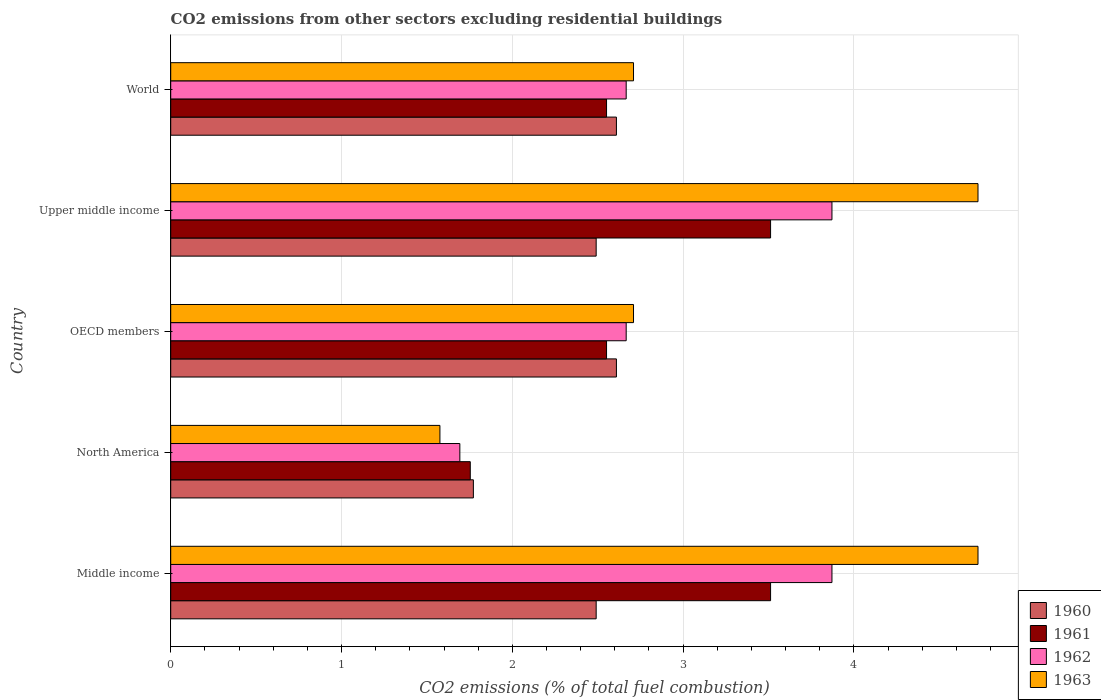How many groups of bars are there?
Ensure brevity in your answer.  5. How many bars are there on the 5th tick from the top?
Provide a short and direct response. 4. What is the total CO2 emitted in 1961 in Upper middle income?
Keep it short and to the point. 3.51. Across all countries, what is the maximum total CO2 emitted in 1960?
Give a very brief answer. 2.61. Across all countries, what is the minimum total CO2 emitted in 1961?
Offer a very short reply. 1.75. What is the total total CO2 emitted in 1961 in the graph?
Offer a very short reply. 13.88. What is the difference between the total CO2 emitted in 1962 in North America and that in OECD members?
Your response must be concise. -0.97. What is the difference between the total CO2 emitted in 1961 in OECD members and the total CO2 emitted in 1962 in North America?
Your answer should be compact. 0.86. What is the average total CO2 emitted in 1961 per country?
Provide a short and direct response. 2.78. What is the difference between the total CO2 emitted in 1962 and total CO2 emitted in 1961 in Middle income?
Ensure brevity in your answer.  0.36. What is the ratio of the total CO2 emitted in 1961 in North America to that in World?
Ensure brevity in your answer.  0.69. Is the total CO2 emitted in 1960 in Middle income less than that in World?
Keep it short and to the point. Yes. Is the difference between the total CO2 emitted in 1962 in Middle income and Upper middle income greater than the difference between the total CO2 emitted in 1961 in Middle income and Upper middle income?
Make the answer very short. No. What is the difference between the highest and the lowest total CO2 emitted in 1963?
Your response must be concise. 3.15. Is it the case that in every country, the sum of the total CO2 emitted in 1962 and total CO2 emitted in 1961 is greater than the sum of total CO2 emitted in 1963 and total CO2 emitted in 1960?
Provide a succinct answer. No. How many bars are there?
Provide a short and direct response. 20. Are all the bars in the graph horizontal?
Your answer should be compact. Yes. Are the values on the major ticks of X-axis written in scientific E-notation?
Your response must be concise. No. Does the graph contain grids?
Your answer should be very brief. Yes. How are the legend labels stacked?
Give a very brief answer. Vertical. What is the title of the graph?
Make the answer very short. CO2 emissions from other sectors excluding residential buildings. What is the label or title of the X-axis?
Keep it short and to the point. CO2 emissions (% of total fuel combustion). What is the CO2 emissions (% of total fuel combustion) in 1960 in Middle income?
Keep it short and to the point. 2.49. What is the CO2 emissions (% of total fuel combustion) of 1961 in Middle income?
Give a very brief answer. 3.51. What is the CO2 emissions (% of total fuel combustion) of 1962 in Middle income?
Offer a terse response. 3.87. What is the CO2 emissions (% of total fuel combustion) of 1963 in Middle income?
Provide a succinct answer. 4.73. What is the CO2 emissions (% of total fuel combustion) of 1960 in North America?
Provide a succinct answer. 1.77. What is the CO2 emissions (% of total fuel combustion) of 1961 in North America?
Offer a very short reply. 1.75. What is the CO2 emissions (% of total fuel combustion) in 1962 in North America?
Your response must be concise. 1.69. What is the CO2 emissions (% of total fuel combustion) in 1963 in North America?
Your answer should be compact. 1.58. What is the CO2 emissions (% of total fuel combustion) in 1960 in OECD members?
Provide a short and direct response. 2.61. What is the CO2 emissions (% of total fuel combustion) in 1961 in OECD members?
Your response must be concise. 2.55. What is the CO2 emissions (% of total fuel combustion) of 1962 in OECD members?
Ensure brevity in your answer.  2.67. What is the CO2 emissions (% of total fuel combustion) in 1963 in OECD members?
Make the answer very short. 2.71. What is the CO2 emissions (% of total fuel combustion) of 1960 in Upper middle income?
Your answer should be compact. 2.49. What is the CO2 emissions (% of total fuel combustion) of 1961 in Upper middle income?
Give a very brief answer. 3.51. What is the CO2 emissions (% of total fuel combustion) in 1962 in Upper middle income?
Your response must be concise. 3.87. What is the CO2 emissions (% of total fuel combustion) of 1963 in Upper middle income?
Offer a very short reply. 4.73. What is the CO2 emissions (% of total fuel combustion) in 1960 in World?
Make the answer very short. 2.61. What is the CO2 emissions (% of total fuel combustion) of 1961 in World?
Offer a terse response. 2.55. What is the CO2 emissions (% of total fuel combustion) in 1962 in World?
Offer a very short reply. 2.67. What is the CO2 emissions (% of total fuel combustion) in 1963 in World?
Ensure brevity in your answer.  2.71. Across all countries, what is the maximum CO2 emissions (% of total fuel combustion) in 1960?
Make the answer very short. 2.61. Across all countries, what is the maximum CO2 emissions (% of total fuel combustion) in 1961?
Offer a terse response. 3.51. Across all countries, what is the maximum CO2 emissions (% of total fuel combustion) in 1962?
Keep it short and to the point. 3.87. Across all countries, what is the maximum CO2 emissions (% of total fuel combustion) in 1963?
Keep it short and to the point. 4.73. Across all countries, what is the minimum CO2 emissions (% of total fuel combustion) in 1960?
Your response must be concise. 1.77. Across all countries, what is the minimum CO2 emissions (% of total fuel combustion) of 1961?
Keep it short and to the point. 1.75. Across all countries, what is the minimum CO2 emissions (% of total fuel combustion) of 1962?
Ensure brevity in your answer.  1.69. Across all countries, what is the minimum CO2 emissions (% of total fuel combustion) in 1963?
Your answer should be very brief. 1.58. What is the total CO2 emissions (% of total fuel combustion) in 1960 in the graph?
Provide a short and direct response. 11.97. What is the total CO2 emissions (% of total fuel combustion) of 1961 in the graph?
Provide a succinct answer. 13.88. What is the total CO2 emissions (% of total fuel combustion) of 1962 in the graph?
Your answer should be compact. 14.77. What is the total CO2 emissions (% of total fuel combustion) in 1963 in the graph?
Provide a succinct answer. 16.45. What is the difference between the CO2 emissions (% of total fuel combustion) of 1960 in Middle income and that in North America?
Your answer should be very brief. 0.72. What is the difference between the CO2 emissions (% of total fuel combustion) of 1961 in Middle income and that in North America?
Provide a short and direct response. 1.76. What is the difference between the CO2 emissions (% of total fuel combustion) of 1962 in Middle income and that in North America?
Offer a very short reply. 2.18. What is the difference between the CO2 emissions (% of total fuel combustion) in 1963 in Middle income and that in North America?
Make the answer very short. 3.15. What is the difference between the CO2 emissions (% of total fuel combustion) in 1960 in Middle income and that in OECD members?
Provide a short and direct response. -0.12. What is the difference between the CO2 emissions (% of total fuel combustion) in 1961 in Middle income and that in OECD members?
Keep it short and to the point. 0.96. What is the difference between the CO2 emissions (% of total fuel combustion) in 1962 in Middle income and that in OECD members?
Keep it short and to the point. 1.2. What is the difference between the CO2 emissions (% of total fuel combustion) of 1963 in Middle income and that in OECD members?
Make the answer very short. 2.02. What is the difference between the CO2 emissions (% of total fuel combustion) of 1960 in Middle income and that in Upper middle income?
Ensure brevity in your answer.  0. What is the difference between the CO2 emissions (% of total fuel combustion) of 1963 in Middle income and that in Upper middle income?
Your answer should be compact. 0. What is the difference between the CO2 emissions (% of total fuel combustion) in 1960 in Middle income and that in World?
Your response must be concise. -0.12. What is the difference between the CO2 emissions (% of total fuel combustion) of 1961 in Middle income and that in World?
Keep it short and to the point. 0.96. What is the difference between the CO2 emissions (% of total fuel combustion) of 1962 in Middle income and that in World?
Keep it short and to the point. 1.2. What is the difference between the CO2 emissions (% of total fuel combustion) of 1963 in Middle income and that in World?
Offer a terse response. 2.02. What is the difference between the CO2 emissions (% of total fuel combustion) in 1960 in North America and that in OECD members?
Your answer should be compact. -0.84. What is the difference between the CO2 emissions (% of total fuel combustion) of 1961 in North America and that in OECD members?
Make the answer very short. -0.8. What is the difference between the CO2 emissions (% of total fuel combustion) in 1962 in North America and that in OECD members?
Keep it short and to the point. -0.97. What is the difference between the CO2 emissions (% of total fuel combustion) in 1963 in North America and that in OECD members?
Offer a terse response. -1.13. What is the difference between the CO2 emissions (% of total fuel combustion) in 1960 in North America and that in Upper middle income?
Your answer should be compact. -0.72. What is the difference between the CO2 emissions (% of total fuel combustion) of 1961 in North America and that in Upper middle income?
Offer a terse response. -1.76. What is the difference between the CO2 emissions (% of total fuel combustion) in 1962 in North America and that in Upper middle income?
Your response must be concise. -2.18. What is the difference between the CO2 emissions (% of total fuel combustion) of 1963 in North America and that in Upper middle income?
Your response must be concise. -3.15. What is the difference between the CO2 emissions (% of total fuel combustion) in 1960 in North America and that in World?
Offer a very short reply. -0.84. What is the difference between the CO2 emissions (% of total fuel combustion) in 1961 in North America and that in World?
Offer a very short reply. -0.8. What is the difference between the CO2 emissions (% of total fuel combustion) of 1962 in North America and that in World?
Offer a very short reply. -0.97. What is the difference between the CO2 emissions (% of total fuel combustion) in 1963 in North America and that in World?
Ensure brevity in your answer.  -1.13. What is the difference between the CO2 emissions (% of total fuel combustion) in 1960 in OECD members and that in Upper middle income?
Offer a very short reply. 0.12. What is the difference between the CO2 emissions (% of total fuel combustion) in 1961 in OECD members and that in Upper middle income?
Your answer should be very brief. -0.96. What is the difference between the CO2 emissions (% of total fuel combustion) of 1962 in OECD members and that in Upper middle income?
Your answer should be very brief. -1.2. What is the difference between the CO2 emissions (% of total fuel combustion) of 1963 in OECD members and that in Upper middle income?
Offer a terse response. -2.02. What is the difference between the CO2 emissions (% of total fuel combustion) in 1961 in OECD members and that in World?
Offer a very short reply. 0. What is the difference between the CO2 emissions (% of total fuel combustion) in 1962 in OECD members and that in World?
Your answer should be very brief. 0. What is the difference between the CO2 emissions (% of total fuel combustion) in 1960 in Upper middle income and that in World?
Your answer should be compact. -0.12. What is the difference between the CO2 emissions (% of total fuel combustion) of 1961 in Upper middle income and that in World?
Provide a short and direct response. 0.96. What is the difference between the CO2 emissions (% of total fuel combustion) of 1962 in Upper middle income and that in World?
Your answer should be very brief. 1.2. What is the difference between the CO2 emissions (% of total fuel combustion) in 1963 in Upper middle income and that in World?
Provide a succinct answer. 2.02. What is the difference between the CO2 emissions (% of total fuel combustion) in 1960 in Middle income and the CO2 emissions (% of total fuel combustion) in 1961 in North America?
Give a very brief answer. 0.74. What is the difference between the CO2 emissions (% of total fuel combustion) in 1960 in Middle income and the CO2 emissions (% of total fuel combustion) in 1962 in North America?
Your answer should be very brief. 0.8. What is the difference between the CO2 emissions (% of total fuel combustion) of 1960 in Middle income and the CO2 emissions (% of total fuel combustion) of 1963 in North America?
Make the answer very short. 0.91. What is the difference between the CO2 emissions (% of total fuel combustion) in 1961 in Middle income and the CO2 emissions (% of total fuel combustion) in 1962 in North America?
Offer a terse response. 1.82. What is the difference between the CO2 emissions (% of total fuel combustion) of 1961 in Middle income and the CO2 emissions (% of total fuel combustion) of 1963 in North America?
Provide a short and direct response. 1.94. What is the difference between the CO2 emissions (% of total fuel combustion) in 1962 in Middle income and the CO2 emissions (% of total fuel combustion) in 1963 in North America?
Your response must be concise. 2.3. What is the difference between the CO2 emissions (% of total fuel combustion) of 1960 in Middle income and the CO2 emissions (% of total fuel combustion) of 1961 in OECD members?
Your response must be concise. -0.06. What is the difference between the CO2 emissions (% of total fuel combustion) of 1960 in Middle income and the CO2 emissions (% of total fuel combustion) of 1962 in OECD members?
Offer a very short reply. -0.18. What is the difference between the CO2 emissions (% of total fuel combustion) in 1960 in Middle income and the CO2 emissions (% of total fuel combustion) in 1963 in OECD members?
Ensure brevity in your answer.  -0.22. What is the difference between the CO2 emissions (% of total fuel combustion) in 1961 in Middle income and the CO2 emissions (% of total fuel combustion) in 1962 in OECD members?
Provide a succinct answer. 0.85. What is the difference between the CO2 emissions (% of total fuel combustion) of 1961 in Middle income and the CO2 emissions (% of total fuel combustion) of 1963 in OECD members?
Offer a very short reply. 0.8. What is the difference between the CO2 emissions (% of total fuel combustion) of 1962 in Middle income and the CO2 emissions (% of total fuel combustion) of 1963 in OECD members?
Provide a short and direct response. 1.16. What is the difference between the CO2 emissions (% of total fuel combustion) in 1960 in Middle income and the CO2 emissions (% of total fuel combustion) in 1961 in Upper middle income?
Your answer should be very brief. -1.02. What is the difference between the CO2 emissions (% of total fuel combustion) of 1960 in Middle income and the CO2 emissions (% of total fuel combustion) of 1962 in Upper middle income?
Make the answer very short. -1.38. What is the difference between the CO2 emissions (% of total fuel combustion) of 1960 in Middle income and the CO2 emissions (% of total fuel combustion) of 1963 in Upper middle income?
Give a very brief answer. -2.24. What is the difference between the CO2 emissions (% of total fuel combustion) of 1961 in Middle income and the CO2 emissions (% of total fuel combustion) of 1962 in Upper middle income?
Offer a very short reply. -0.36. What is the difference between the CO2 emissions (% of total fuel combustion) in 1961 in Middle income and the CO2 emissions (% of total fuel combustion) in 1963 in Upper middle income?
Your answer should be compact. -1.21. What is the difference between the CO2 emissions (% of total fuel combustion) of 1962 in Middle income and the CO2 emissions (% of total fuel combustion) of 1963 in Upper middle income?
Your answer should be very brief. -0.85. What is the difference between the CO2 emissions (% of total fuel combustion) of 1960 in Middle income and the CO2 emissions (% of total fuel combustion) of 1961 in World?
Make the answer very short. -0.06. What is the difference between the CO2 emissions (% of total fuel combustion) in 1960 in Middle income and the CO2 emissions (% of total fuel combustion) in 1962 in World?
Offer a terse response. -0.18. What is the difference between the CO2 emissions (% of total fuel combustion) of 1960 in Middle income and the CO2 emissions (% of total fuel combustion) of 1963 in World?
Make the answer very short. -0.22. What is the difference between the CO2 emissions (% of total fuel combustion) of 1961 in Middle income and the CO2 emissions (% of total fuel combustion) of 1962 in World?
Provide a succinct answer. 0.85. What is the difference between the CO2 emissions (% of total fuel combustion) in 1961 in Middle income and the CO2 emissions (% of total fuel combustion) in 1963 in World?
Ensure brevity in your answer.  0.8. What is the difference between the CO2 emissions (% of total fuel combustion) in 1962 in Middle income and the CO2 emissions (% of total fuel combustion) in 1963 in World?
Give a very brief answer. 1.16. What is the difference between the CO2 emissions (% of total fuel combustion) in 1960 in North America and the CO2 emissions (% of total fuel combustion) in 1961 in OECD members?
Offer a very short reply. -0.78. What is the difference between the CO2 emissions (% of total fuel combustion) of 1960 in North America and the CO2 emissions (% of total fuel combustion) of 1962 in OECD members?
Offer a very short reply. -0.89. What is the difference between the CO2 emissions (% of total fuel combustion) in 1960 in North America and the CO2 emissions (% of total fuel combustion) in 1963 in OECD members?
Provide a succinct answer. -0.94. What is the difference between the CO2 emissions (% of total fuel combustion) of 1961 in North America and the CO2 emissions (% of total fuel combustion) of 1962 in OECD members?
Your answer should be very brief. -0.91. What is the difference between the CO2 emissions (% of total fuel combustion) of 1961 in North America and the CO2 emissions (% of total fuel combustion) of 1963 in OECD members?
Provide a short and direct response. -0.96. What is the difference between the CO2 emissions (% of total fuel combustion) of 1962 in North America and the CO2 emissions (% of total fuel combustion) of 1963 in OECD members?
Your response must be concise. -1.02. What is the difference between the CO2 emissions (% of total fuel combustion) in 1960 in North America and the CO2 emissions (% of total fuel combustion) in 1961 in Upper middle income?
Ensure brevity in your answer.  -1.74. What is the difference between the CO2 emissions (% of total fuel combustion) of 1960 in North America and the CO2 emissions (% of total fuel combustion) of 1962 in Upper middle income?
Offer a very short reply. -2.1. What is the difference between the CO2 emissions (% of total fuel combustion) in 1960 in North America and the CO2 emissions (% of total fuel combustion) in 1963 in Upper middle income?
Offer a terse response. -2.95. What is the difference between the CO2 emissions (% of total fuel combustion) of 1961 in North America and the CO2 emissions (% of total fuel combustion) of 1962 in Upper middle income?
Make the answer very short. -2.12. What is the difference between the CO2 emissions (% of total fuel combustion) of 1961 in North America and the CO2 emissions (% of total fuel combustion) of 1963 in Upper middle income?
Your answer should be very brief. -2.97. What is the difference between the CO2 emissions (% of total fuel combustion) of 1962 in North America and the CO2 emissions (% of total fuel combustion) of 1963 in Upper middle income?
Ensure brevity in your answer.  -3.03. What is the difference between the CO2 emissions (% of total fuel combustion) of 1960 in North America and the CO2 emissions (% of total fuel combustion) of 1961 in World?
Keep it short and to the point. -0.78. What is the difference between the CO2 emissions (% of total fuel combustion) of 1960 in North America and the CO2 emissions (% of total fuel combustion) of 1962 in World?
Make the answer very short. -0.89. What is the difference between the CO2 emissions (% of total fuel combustion) of 1960 in North America and the CO2 emissions (% of total fuel combustion) of 1963 in World?
Offer a terse response. -0.94. What is the difference between the CO2 emissions (% of total fuel combustion) in 1961 in North America and the CO2 emissions (% of total fuel combustion) in 1962 in World?
Provide a succinct answer. -0.91. What is the difference between the CO2 emissions (% of total fuel combustion) of 1961 in North America and the CO2 emissions (% of total fuel combustion) of 1963 in World?
Provide a short and direct response. -0.96. What is the difference between the CO2 emissions (% of total fuel combustion) in 1962 in North America and the CO2 emissions (% of total fuel combustion) in 1963 in World?
Keep it short and to the point. -1.02. What is the difference between the CO2 emissions (% of total fuel combustion) of 1960 in OECD members and the CO2 emissions (% of total fuel combustion) of 1961 in Upper middle income?
Make the answer very short. -0.9. What is the difference between the CO2 emissions (% of total fuel combustion) of 1960 in OECD members and the CO2 emissions (% of total fuel combustion) of 1962 in Upper middle income?
Offer a terse response. -1.26. What is the difference between the CO2 emissions (% of total fuel combustion) of 1960 in OECD members and the CO2 emissions (% of total fuel combustion) of 1963 in Upper middle income?
Keep it short and to the point. -2.12. What is the difference between the CO2 emissions (% of total fuel combustion) of 1961 in OECD members and the CO2 emissions (% of total fuel combustion) of 1962 in Upper middle income?
Make the answer very short. -1.32. What is the difference between the CO2 emissions (% of total fuel combustion) of 1961 in OECD members and the CO2 emissions (% of total fuel combustion) of 1963 in Upper middle income?
Ensure brevity in your answer.  -2.17. What is the difference between the CO2 emissions (% of total fuel combustion) of 1962 in OECD members and the CO2 emissions (% of total fuel combustion) of 1963 in Upper middle income?
Offer a terse response. -2.06. What is the difference between the CO2 emissions (% of total fuel combustion) of 1960 in OECD members and the CO2 emissions (% of total fuel combustion) of 1961 in World?
Your answer should be compact. 0.06. What is the difference between the CO2 emissions (% of total fuel combustion) of 1960 in OECD members and the CO2 emissions (% of total fuel combustion) of 1962 in World?
Make the answer very short. -0.06. What is the difference between the CO2 emissions (% of total fuel combustion) in 1960 in OECD members and the CO2 emissions (% of total fuel combustion) in 1963 in World?
Provide a succinct answer. -0.1. What is the difference between the CO2 emissions (% of total fuel combustion) in 1961 in OECD members and the CO2 emissions (% of total fuel combustion) in 1962 in World?
Offer a terse response. -0.12. What is the difference between the CO2 emissions (% of total fuel combustion) of 1961 in OECD members and the CO2 emissions (% of total fuel combustion) of 1963 in World?
Your answer should be compact. -0.16. What is the difference between the CO2 emissions (% of total fuel combustion) of 1962 in OECD members and the CO2 emissions (% of total fuel combustion) of 1963 in World?
Make the answer very short. -0.04. What is the difference between the CO2 emissions (% of total fuel combustion) in 1960 in Upper middle income and the CO2 emissions (% of total fuel combustion) in 1961 in World?
Your answer should be compact. -0.06. What is the difference between the CO2 emissions (% of total fuel combustion) in 1960 in Upper middle income and the CO2 emissions (% of total fuel combustion) in 1962 in World?
Offer a very short reply. -0.18. What is the difference between the CO2 emissions (% of total fuel combustion) of 1960 in Upper middle income and the CO2 emissions (% of total fuel combustion) of 1963 in World?
Ensure brevity in your answer.  -0.22. What is the difference between the CO2 emissions (% of total fuel combustion) in 1961 in Upper middle income and the CO2 emissions (% of total fuel combustion) in 1962 in World?
Make the answer very short. 0.85. What is the difference between the CO2 emissions (% of total fuel combustion) in 1961 in Upper middle income and the CO2 emissions (% of total fuel combustion) in 1963 in World?
Make the answer very short. 0.8. What is the difference between the CO2 emissions (% of total fuel combustion) of 1962 in Upper middle income and the CO2 emissions (% of total fuel combustion) of 1963 in World?
Give a very brief answer. 1.16. What is the average CO2 emissions (% of total fuel combustion) of 1960 per country?
Your answer should be compact. 2.39. What is the average CO2 emissions (% of total fuel combustion) in 1961 per country?
Your answer should be very brief. 2.78. What is the average CO2 emissions (% of total fuel combustion) in 1962 per country?
Offer a very short reply. 2.95. What is the average CO2 emissions (% of total fuel combustion) of 1963 per country?
Provide a succinct answer. 3.29. What is the difference between the CO2 emissions (% of total fuel combustion) in 1960 and CO2 emissions (% of total fuel combustion) in 1961 in Middle income?
Offer a terse response. -1.02. What is the difference between the CO2 emissions (% of total fuel combustion) in 1960 and CO2 emissions (% of total fuel combustion) in 1962 in Middle income?
Give a very brief answer. -1.38. What is the difference between the CO2 emissions (% of total fuel combustion) of 1960 and CO2 emissions (% of total fuel combustion) of 1963 in Middle income?
Provide a short and direct response. -2.24. What is the difference between the CO2 emissions (% of total fuel combustion) of 1961 and CO2 emissions (% of total fuel combustion) of 1962 in Middle income?
Make the answer very short. -0.36. What is the difference between the CO2 emissions (% of total fuel combustion) in 1961 and CO2 emissions (% of total fuel combustion) in 1963 in Middle income?
Give a very brief answer. -1.21. What is the difference between the CO2 emissions (% of total fuel combustion) of 1962 and CO2 emissions (% of total fuel combustion) of 1963 in Middle income?
Provide a succinct answer. -0.85. What is the difference between the CO2 emissions (% of total fuel combustion) of 1960 and CO2 emissions (% of total fuel combustion) of 1961 in North America?
Your answer should be very brief. 0.02. What is the difference between the CO2 emissions (% of total fuel combustion) of 1960 and CO2 emissions (% of total fuel combustion) of 1962 in North America?
Ensure brevity in your answer.  0.08. What is the difference between the CO2 emissions (% of total fuel combustion) in 1960 and CO2 emissions (% of total fuel combustion) in 1963 in North America?
Offer a very short reply. 0.2. What is the difference between the CO2 emissions (% of total fuel combustion) of 1961 and CO2 emissions (% of total fuel combustion) of 1962 in North America?
Your answer should be very brief. 0.06. What is the difference between the CO2 emissions (% of total fuel combustion) in 1961 and CO2 emissions (% of total fuel combustion) in 1963 in North America?
Provide a succinct answer. 0.18. What is the difference between the CO2 emissions (% of total fuel combustion) in 1962 and CO2 emissions (% of total fuel combustion) in 1963 in North America?
Provide a succinct answer. 0.12. What is the difference between the CO2 emissions (% of total fuel combustion) in 1960 and CO2 emissions (% of total fuel combustion) in 1961 in OECD members?
Your response must be concise. 0.06. What is the difference between the CO2 emissions (% of total fuel combustion) of 1960 and CO2 emissions (% of total fuel combustion) of 1962 in OECD members?
Your answer should be very brief. -0.06. What is the difference between the CO2 emissions (% of total fuel combustion) of 1960 and CO2 emissions (% of total fuel combustion) of 1963 in OECD members?
Make the answer very short. -0.1. What is the difference between the CO2 emissions (% of total fuel combustion) in 1961 and CO2 emissions (% of total fuel combustion) in 1962 in OECD members?
Give a very brief answer. -0.12. What is the difference between the CO2 emissions (% of total fuel combustion) in 1961 and CO2 emissions (% of total fuel combustion) in 1963 in OECD members?
Offer a terse response. -0.16. What is the difference between the CO2 emissions (% of total fuel combustion) in 1962 and CO2 emissions (% of total fuel combustion) in 1963 in OECD members?
Give a very brief answer. -0.04. What is the difference between the CO2 emissions (% of total fuel combustion) in 1960 and CO2 emissions (% of total fuel combustion) in 1961 in Upper middle income?
Provide a succinct answer. -1.02. What is the difference between the CO2 emissions (% of total fuel combustion) in 1960 and CO2 emissions (% of total fuel combustion) in 1962 in Upper middle income?
Keep it short and to the point. -1.38. What is the difference between the CO2 emissions (% of total fuel combustion) of 1960 and CO2 emissions (% of total fuel combustion) of 1963 in Upper middle income?
Your response must be concise. -2.24. What is the difference between the CO2 emissions (% of total fuel combustion) in 1961 and CO2 emissions (% of total fuel combustion) in 1962 in Upper middle income?
Your answer should be compact. -0.36. What is the difference between the CO2 emissions (% of total fuel combustion) of 1961 and CO2 emissions (% of total fuel combustion) of 1963 in Upper middle income?
Ensure brevity in your answer.  -1.21. What is the difference between the CO2 emissions (% of total fuel combustion) of 1962 and CO2 emissions (% of total fuel combustion) of 1963 in Upper middle income?
Offer a very short reply. -0.85. What is the difference between the CO2 emissions (% of total fuel combustion) of 1960 and CO2 emissions (% of total fuel combustion) of 1961 in World?
Provide a short and direct response. 0.06. What is the difference between the CO2 emissions (% of total fuel combustion) of 1960 and CO2 emissions (% of total fuel combustion) of 1962 in World?
Your response must be concise. -0.06. What is the difference between the CO2 emissions (% of total fuel combustion) in 1960 and CO2 emissions (% of total fuel combustion) in 1963 in World?
Offer a very short reply. -0.1. What is the difference between the CO2 emissions (% of total fuel combustion) in 1961 and CO2 emissions (% of total fuel combustion) in 1962 in World?
Make the answer very short. -0.12. What is the difference between the CO2 emissions (% of total fuel combustion) of 1961 and CO2 emissions (% of total fuel combustion) of 1963 in World?
Keep it short and to the point. -0.16. What is the difference between the CO2 emissions (% of total fuel combustion) of 1962 and CO2 emissions (% of total fuel combustion) of 1963 in World?
Offer a terse response. -0.04. What is the ratio of the CO2 emissions (% of total fuel combustion) in 1960 in Middle income to that in North America?
Ensure brevity in your answer.  1.41. What is the ratio of the CO2 emissions (% of total fuel combustion) in 1961 in Middle income to that in North America?
Provide a short and direct response. 2. What is the ratio of the CO2 emissions (% of total fuel combustion) of 1962 in Middle income to that in North America?
Your answer should be compact. 2.29. What is the ratio of the CO2 emissions (% of total fuel combustion) of 1963 in Middle income to that in North America?
Keep it short and to the point. 3. What is the ratio of the CO2 emissions (% of total fuel combustion) in 1960 in Middle income to that in OECD members?
Provide a short and direct response. 0.95. What is the ratio of the CO2 emissions (% of total fuel combustion) of 1961 in Middle income to that in OECD members?
Your response must be concise. 1.38. What is the ratio of the CO2 emissions (% of total fuel combustion) in 1962 in Middle income to that in OECD members?
Your answer should be compact. 1.45. What is the ratio of the CO2 emissions (% of total fuel combustion) in 1963 in Middle income to that in OECD members?
Your response must be concise. 1.74. What is the ratio of the CO2 emissions (% of total fuel combustion) in 1961 in Middle income to that in Upper middle income?
Keep it short and to the point. 1. What is the ratio of the CO2 emissions (% of total fuel combustion) in 1960 in Middle income to that in World?
Keep it short and to the point. 0.95. What is the ratio of the CO2 emissions (% of total fuel combustion) in 1961 in Middle income to that in World?
Make the answer very short. 1.38. What is the ratio of the CO2 emissions (% of total fuel combustion) in 1962 in Middle income to that in World?
Provide a short and direct response. 1.45. What is the ratio of the CO2 emissions (% of total fuel combustion) in 1963 in Middle income to that in World?
Give a very brief answer. 1.74. What is the ratio of the CO2 emissions (% of total fuel combustion) of 1960 in North America to that in OECD members?
Give a very brief answer. 0.68. What is the ratio of the CO2 emissions (% of total fuel combustion) of 1961 in North America to that in OECD members?
Make the answer very short. 0.69. What is the ratio of the CO2 emissions (% of total fuel combustion) in 1962 in North America to that in OECD members?
Offer a terse response. 0.63. What is the ratio of the CO2 emissions (% of total fuel combustion) of 1963 in North America to that in OECD members?
Keep it short and to the point. 0.58. What is the ratio of the CO2 emissions (% of total fuel combustion) of 1960 in North America to that in Upper middle income?
Ensure brevity in your answer.  0.71. What is the ratio of the CO2 emissions (% of total fuel combustion) in 1961 in North America to that in Upper middle income?
Give a very brief answer. 0.5. What is the ratio of the CO2 emissions (% of total fuel combustion) of 1962 in North America to that in Upper middle income?
Ensure brevity in your answer.  0.44. What is the ratio of the CO2 emissions (% of total fuel combustion) of 1963 in North America to that in Upper middle income?
Your answer should be very brief. 0.33. What is the ratio of the CO2 emissions (% of total fuel combustion) of 1960 in North America to that in World?
Make the answer very short. 0.68. What is the ratio of the CO2 emissions (% of total fuel combustion) of 1961 in North America to that in World?
Your answer should be compact. 0.69. What is the ratio of the CO2 emissions (% of total fuel combustion) of 1962 in North America to that in World?
Offer a very short reply. 0.63. What is the ratio of the CO2 emissions (% of total fuel combustion) of 1963 in North America to that in World?
Your answer should be compact. 0.58. What is the ratio of the CO2 emissions (% of total fuel combustion) of 1960 in OECD members to that in Upper middle income?
Offer a very short reply. 1.05. What is the ratio of the CO2 emissions (% of total fuel combustion) in 1961 in OECD members to that in Upper middle income?
Ensure brevity in your answer.  0.73. What is the ratio of the CO2 emissions (% of total fuel combustion) of 1962 in OECD members to that in Upper middle income?
Offer a very short reply. 0.69. What is the ratio of the CO2 emissions (% of total fuel combustion) in 1963 in OECD members to that in Upper middle income?
Provide a succinct answer. 0.57. What is the ratio of the CO2 emissions (% of total fuel combustion) of 1960 in OECD members to that in World?
Provide a short and direct response. 1. What is the ratio of the CO2 emissions (% of total fuel combustion) in 1961 in OECD members to that in World?
Give a very brief answer. 1. What is the ratio of the CO2 emissions (% of total fuel combustion) in 1960 in Upper middle income to that in World?
Ensure brevity in your answer.  0.95. What is the ratio of the CO2 emissions (% of total fuel combustion) in 1961 in Upper middle income to that in World?
Make the answer very short. 1.38. What is the ratio of the CO2 emissions (% of total fuel combustion) of 1962 in Upper middle income to that in World?
Your answer should be compact. 1.45. What is the ratio of the CO2 emissions (% of total fuel combustion) in 1963 in Upper middle income to that in World?
Offer a very short reply. 1.74. What is the difference between the highest and the second highest CO2 emissions (% of total fuel combustion) of 1960?
Ensure brevity in your answer.  0. What is the difference between the highest and the second highest CO2 emissions (% of total fuel combustion) in 1963?
Give a very brief answer. 0. What is the difference between the highest and the lowest CO2 emissions (% of total fuel combustion) in 1960?
Offer a terse response. 0.84. What is the difference between the highest and the lowest CO2 emissions (% of total fuel combustion) of 1961?
Your answer should be compact. 1.76. What is the difference between the highest and the lowest CO2 emissions (% of total fuel combustion) of 1962?
Ensure brevity in your answer.  2.18. What is the difference between the highest and the lowest CO2 emissions (% of total fuel combustion) in 1963?
Give a very brief answer. 3.15. 